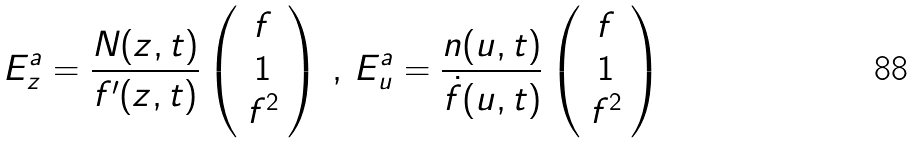<formula> <loc_0><loc_0><loc_500><loc_500>E ^ { a } _ { z } = \frac { N ( z , t ) } { f ^ { \prime } ( z , t ) } \left ( \begin{array} { c } f \\ 1 \\ f ^ { 2 } \end{array} \right ) \, , \, E ^ { a } _ { u } = \frac { n ( u , t ) } { \dot { f } ( u , t ) } \left ( \begin{array} { c } f \\ 1 \\ f ^ { 2 } \end{array} \right )</formula> 